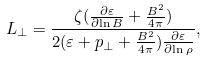Convert formula to latex. <formula><loc_0><loc_0><loc_500><loc_500>L _ { \perp } = \frac { \zeta ( \frac { \partial \varepsilon } { \partial { \ln B } } + \frac { B ^ { 2 } } { 4 \pi } ) } { 2 ( \varepsilon + p _ { \perp } + \frac { B ^ { 2 } } { 4 \pi } ) \frac { \partial \varepsilon } { \partial { \ln \rho } } } ,</formula> 